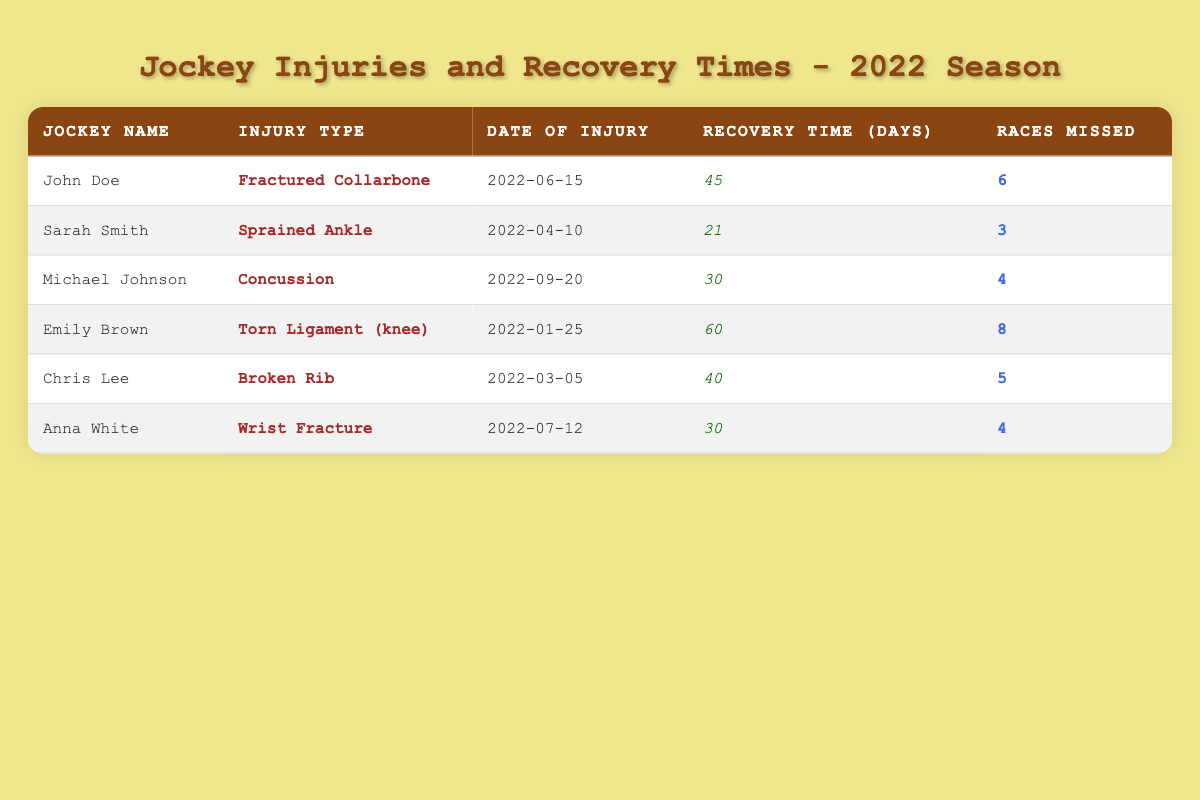What is the recovery time for Sarah Smith? The recovery time is found in the recovery time column corresponding to the row for Sarah Smith. It shows that her recovery time is 21 days.
Answer: 21 days How many races did John Doe miss due to his injury? The number of races missed by John Doe is stated in the races missed column. According to the table, he missed 6 races.
Answer: 6 races Which jockey had the longest recovery time? To find the longest recovery time, I compare the recovery times of all the jockeys. Looking through the recovery times, Emily Brown had the highest recovery time of 60 days.
Answer: Emily Brown Is the injury type for Chris Lee a wrist fracture? I can directly check the injury type for Chris Lee in the table. It shows that Chris Lee suffered from a broken rib, not a wrist fracture.
Answer: No What is the total number of races missed by all jockeys combined? To find the total, I need to sum the races missed for all jockeys: 6 (John Doe) + 3 (Sarah Smith) + 4 (Michael Johnson) + 8 (Emily Brown) + 5 (Chris Lee) + 4 (Anna White) = 30.
Answer: 30 races How many jockeys had recovery times less than or equal to 30 days? I need to count how many recovery times are 30 days or less. Looking at the recovery times, Sarah Smith (21 days), Michael Johnson (30 days), Anna White (30 days) qualify, making a total of 3 jockeys.
Answer: 3 jockeys What injury did Michael Johnson sustain? The injury type for Michael Johnson is found in the corresponding row within the injury type column. It indicates that he sustained a concussion.
Answer: Concussion Which injury type resulted in the most races missed? To identify the injury type with the most races missed, I will observe the races missed column. Emily Brown's injured type (Torn Ligament) corresponds to the highest races missed count of 8.
Answer: Torn Ligament (knee) 